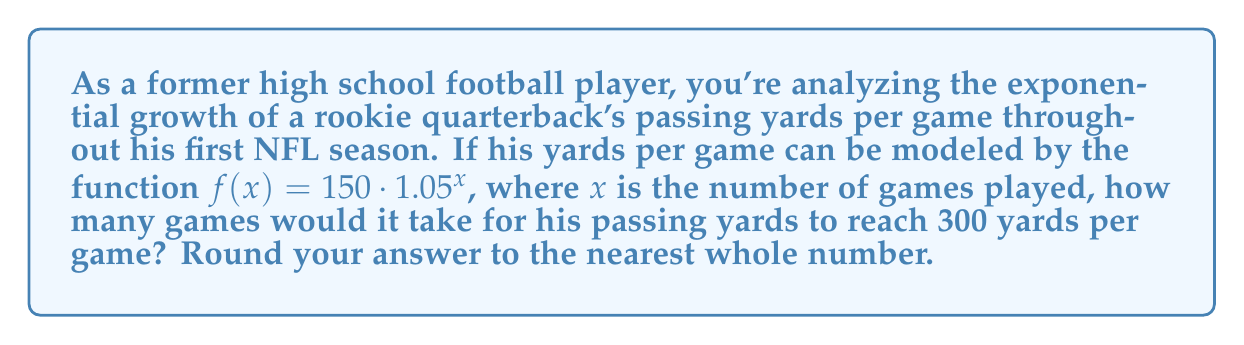Can you answer this question? Let's approach this step-by-step:

1) We need to find $x$ when $f(x) = 300$. This can be written as an equation:

   $300 = 150 \cdot 1.05^x$

2) Divide both sides by 150:

   $2 = 1.05^x$

3) Now, we need to solve for $x$. This is where logarithms come in handy. Take the logarithm (base 1.05) of both sides:

   $\log_{1.05}(2) = \log_{1.05}(1.05^x)$

4) The right side simplifies due to the logarithm rule $\log_a(a^x) = x$:

   $\log_{1.05}(2) = x$

5) We can change this to natural logarithm (ln) for easier calculation:

   $x = \frac{\ln(2)}{\ln(1.05)}$

6) Using a calculator:

   $x \approx 14.2067$

7) Rounding to the nearest whole number:

   $x \approx 14$ games
Answer: 14 games 